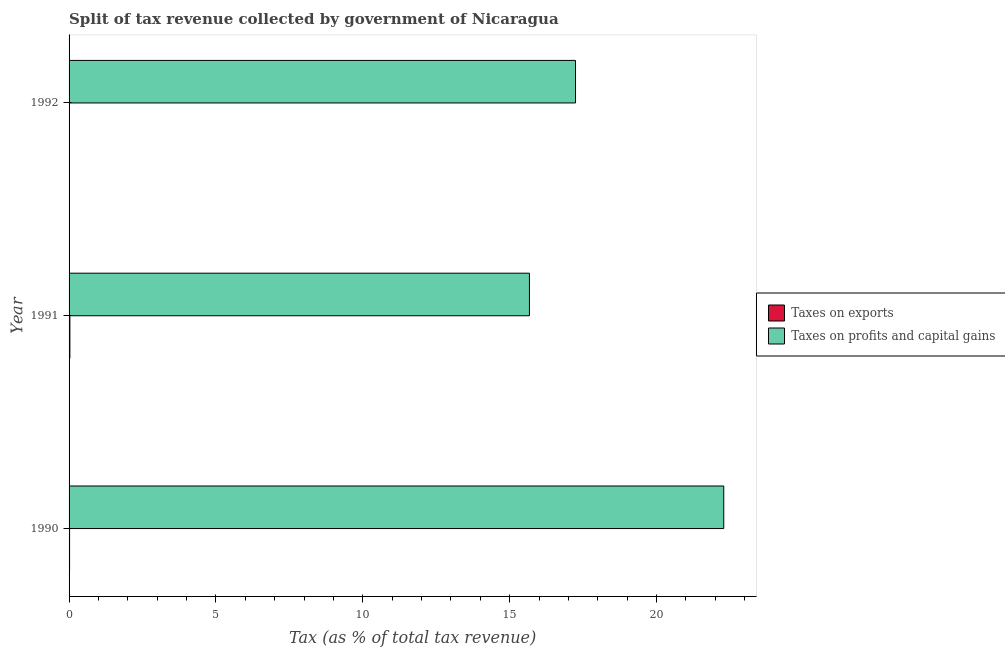How many different coloured bars are there?
Keep it short and to the point. 2. How many groups of bars are there?
Provide a succinct answer. 3. How many bars are there on the 2nd tick from the top?
Your answer should be very brief. 2. How many bars are there on the 2nd tick from the bottom?
Your response must be concise. 2. In how many cases, is the number of bars for a given year not equal to the number of legend labels?
Offer a terse response. 0. What is the percentage of revenue obtained from taxes on profits and capital gains in 1990?
Provide a short and direct response. 22.29. Across all years, what is the maximum percentage of revenue obtained from taxes on profits and capital gains?
Offer a very short reply. 22.29. Across all years, what is the minimum percentage of revenue obtained from taxes on exports?
Your response must be concise. 0.01. In which year was the percentage of revenue obtained from taxes on profits and capital gains maximum?
Offer a terse response. 1990. What is the total percentage of revenue obtained from taxes on profits and capital gains in the graph?
Your answer should be compact. 55.2. What is the difference between the percentage of revenue obtained from taxes on profits and capital gains in 1991 and that in 1992?
Offer a very short reply. -1.57. What is the difference between the percentage of revenue obtained from taxes on exports in 1992 and the percentage of revenue obtained from taxes on profits and capital gains in 1991?
Your response must be concise. -15.67. What is the average percentage of revenue obtained from taxes on exports per year?
Offer a terse response. 0.02. In the year 1990, what is the difference between the percentage of revenue obtained from taxes on profits and capital gains and percentage of revenue obtained from taxes on exports?
Provide a short and direct response. 22.27. In how many years, is the percentage of revenue obtained from taxes on exports greater than 18 %?
Ensure brevity in your answer.  0. What is the ratio of the percentage of revenue obtained from taxes on profits and capital gains in 1991 to that in 1992?
Your answer should be very brief. 0.91. Is the difference between the percentage of revenue obtained from taxes on profits and capital gains in 1991 and 1992 greater than the difference between the percentage of revenue obtained from taxes on exports in 1991 and 1992?
Your answer should be very brief. No. What is the difference between the highest and the second highest percentage of revenue obtained from taxes on exports?
Give a very brief answer. 0.01. What is the difference between the highest and the lowest percentage of revenue obtained from taxes on profits and capital gains?
Provide a succinct answer. 6.62. In how many years, is the percentage of revenue obtained from taxes on exports greater than the average percentage of revenue obtained from taxes on exports taken over all years?
Provide a succinct answer. 2. What does the 2nd bar from the top in 1991 represents?
Provide a short and direct response. Taxes on exports. What does the 2nd bar from the bottom in 1992 represents?
Provide a succinct answer. Taxes on profits and capital gains. Are all the bars in the graph horizontal?
Make the answer very short. Yes. How many years are there in the graph?
Offer a terse response. 3. What is the difference between two consecutive major ticks on the X-axis?
Provide a succinct answer. 5. Are the values on the major ticks of X-axis written in scientific E-notation?
Provide a short and direct response. No. Where does the legend appear in the graph?
Your response must be concise. Center right. How many legend labels are there?
Give a very brief answer. 2. How are the legend labels stacked?
Your response must be concise. Vertical. What is the title of the graph?
Provide a short and direct response. Split of tax revenue collected by government of Nicaragua. What is the label or title of the X-axis?
Offer a very short reply. Tax (as % of total tax revenue). What is the label or title of the Y-axis?
Give a very brief answer. Year. What is the Tax (as % of total tax revenue) in Taxes on exports in 1990?
Provide a short and direct response. 0.02. What is the Tax (as % of total tax revenue) in Taxes on profits and capital gains in 1990?
Keep it short and to the point. 22.29. What is the Tax (as % of total tax revenue) of Taxes on exports in 1991?
Offer a terse response. 0.03. What is the Tax (as % of total tax revenue) of Taxes on profits and capital gains in 1991?
Give a very brief answer. 15.67. What is the Tax (as % of total tax revenue) in Taxes on exports in 1992?
Offer a terse response. 0.01. What is the Tax (as % of total tax revenue) of Taxes on profits and capital gains in 1992?
Provide a succinct answer. 17.24. Across all years, what is the maximum Tax (as % of total tax revenue) in Taxes on exports?
Your answer should be compact. 0.03. Across all years, what is the maximum Tax (as % of total tax revenue) in Taxes on profits and capital gains?
Offer a terse response. 22.29. Across all years, what is the minimum Tax (as % of total tax revenue) of Taxes on exports?
Keep it short and to the point. 0.01. Across all years, what is the minimum Tax (as % of total tax revenue) of Taxes on profits and capital gains?
Your response must be concise. 15.67. What is the total Tax (as % of total tax revenue) of Taxes on profits and capital gains in the graph?
Provide a succinct answer. 55.2. What is the difference between the Tax (as % of total tax revenue) of Taxes on exports in 1990 and that in 1991?
Provide a short and direct response. -0.01. What is the difference between the Tax (as % of total tax revenue) in Taxes on profits and capital gains in 1990 and that in 1991?
Your response must be concise. 6.62. What is the difference between the Tax (as % of total tax revenue) in Taxes on exports in 1990 and that in 1992?
Ensure brevity in your answer.  0.01. What is the difference between the Tax (as % of total tax revenue) in Taxes on profits and capital gains in 1990 and that in 1992?
Ensure brevity in your answer.  5.05. What is the difference between the Tax (as % of total tax revenue) of Taxes on exports in 1991 and that in 1992?
Keep it short and to the point. 0.02. What is the difference between the Tax (as % of total tax revenue) of Taxes on profits and capital gains in 1991 and that in 1992?
Give a very brief answer. -1.57. What is the difference between the Tax (as % of total tax revenue) in Taxes on exports in 1990 and the Tax (as % of total tax revenue) in Taxes on profits and capital gains in 1991?
Your answer should be very brief. -15.66. What is the difference between the Tax (as % of total tax revenue) of Taxes on exports in 1990 and the Tax (as % of total tax revenue) of Taxes on profits and capital gains in 1992?
Offer a terse response. -17.23. What is the difference between the Tax (as % of total tax revenue) of Taxes on exports in 1991 and the Tax (as % of total tax revenue) of Taxes on profits and capital gains in 1992?
Keep it short and to the point. -17.21. What is the average Tax (as % of total tax revenue) of Taxes on exports per year?
Your response must be concise. 0.02. What is the average Tax (as % of total tax revenue) of Taxes on profits and capital gains per year?
Make the answer very short. 18.4. In the year 1990, what is the difference between the Tax (as % of total tax revenue) of Taxes on exports and Tax (as % of total tax revenue) of Taxes on profits and capital gains?
Provide a short and direct response. -22.27. In the year 1991, what is the difference between the Tax (as % of total tax revenue) of Taxes on exports and Tax (as % of total tax revenue) of Taxes on profits and capital gains?
Provide a short and direct response. -15.65. In the year 1992, what is the difference between the Tax (as % of total tax revenue) in Taxes on exports and Tax (as % of total tax revenue) in Taxes on profits and capital gains?
Keep it short and to the point. -17.24. What is the ratio of the Tax (as % of total tax revenue) in Taxes on exports in 1990 to that in 1991?
Provide a succinct answer. 0.62. What is the ratio of the Tax (as % of total tax revenue) in Taxes on profits and capital gains in 1990 to that in 1991?
Provide a short and direct response. 1.42. What is the ratio of the Tax (as % of total tax revenue) in Taxes on exports in 1990 to that in 1992?
Your answer should be very brief. 3.03. What is the ratio of the Tax (as % of total tax revenue) in Taxes on profits and capital gains in 1990 to that in 1992?
Offer a very short reply. 1.29. What is the ratio of the Tax (as % of total tax revenue) in Taxes on exports in 1991 to that in 1992?
Provide a succinct answer. 4.86. What is the ratio of the Tax (as % of total tax revenue) in Taxes on profits and capital gains in 1991 to that in 1992?
Make the answer very short. 0.91. What is the difference between the highest and the second highest Tax (as % of total tax revenue) of Taxes on exports?
Offer a terse response. 0.01. What is the difference between the highest and the second highest Tax (as % of total tax revenue) of Taxes on profits and capital gains?
Give a very brief answer. 5.05. What is the difference between the highest and the lowest Tax (as % of total tax revenue) of Taxes on exports?
Keep it short and to the point. 0.02. What is the difference between the highest and the lowest Tax (as % of total tax revenue) of Taxes on profits and capital gains?
Provide a short and direct response. 6.62. 